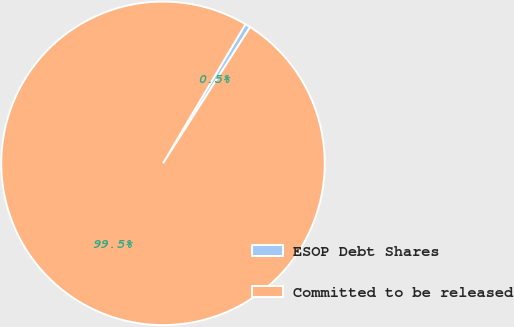<chart> <loc_0><loc_0><loc_500><loc_500><pie_chart><fcel>ESOP Debt Shares<fcel>Committed to be released<nl><fcel>0.54%<fcel>99.46%<nl></chart> 